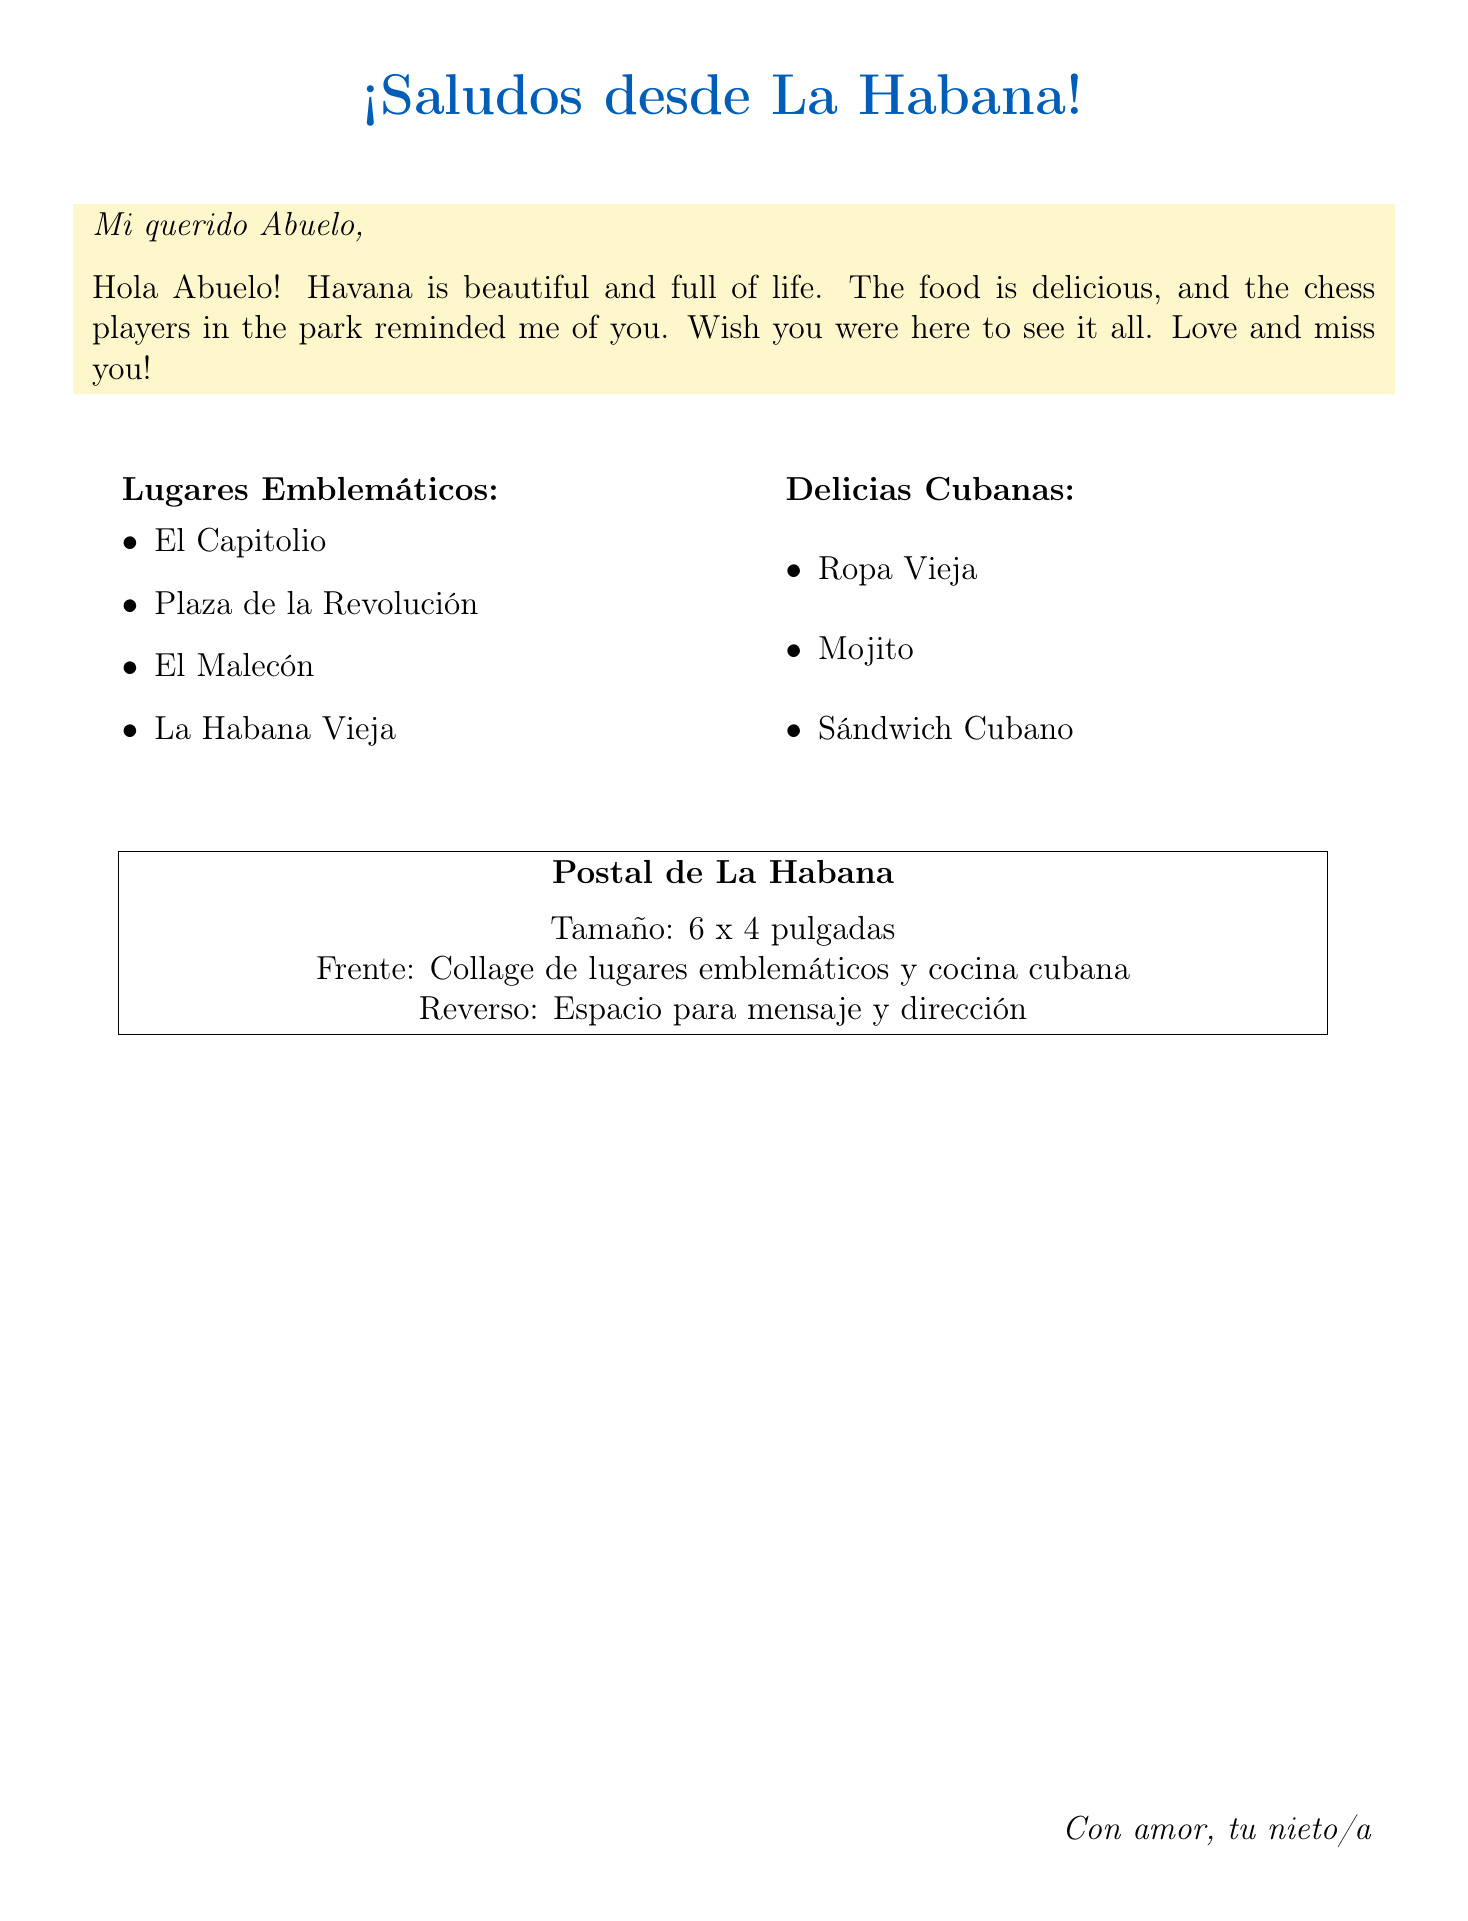What are the dimensions of the postcard? The dimensions are provided in the document as "6 x 4 inches."
Answer: 6 x 4 inches What food is depicted on the postcard? The local cuisine mentioned in the document includes "Ropa Vieja," "Mojito cocktail," and "Cuban sandwich."
Answer: Ropa Vieja, Mojito cocktail, Cuban sandwich Which landmark is mentioned first? The landmarks are listed in bullet points, and the first one is "El Capitolio."
Answer: El Capitolio What does the grandchild say about Havana? The grandchild describes Havana as "beautiful and full of life."
Answer: beautiful and full of life How many emblematic places are listed? The document lists four notable places under "Lugares Emblemáticos."
Answer: Four What is the main theme of the postcard? The postcard features a "Collage of Havana landmarks and Cuban cuisine."
Answer: Collage of Havana landmarks and Cuban cuisine What does the postcard wish for the grandchild's grandfather? The message includes a wish that the grandfather could see Havana, expressing a desire for togetherness.
Answer: Wish you were here What color is used for the header text? The header text color is specified as "cubanblue."
Answer: cubanblue 